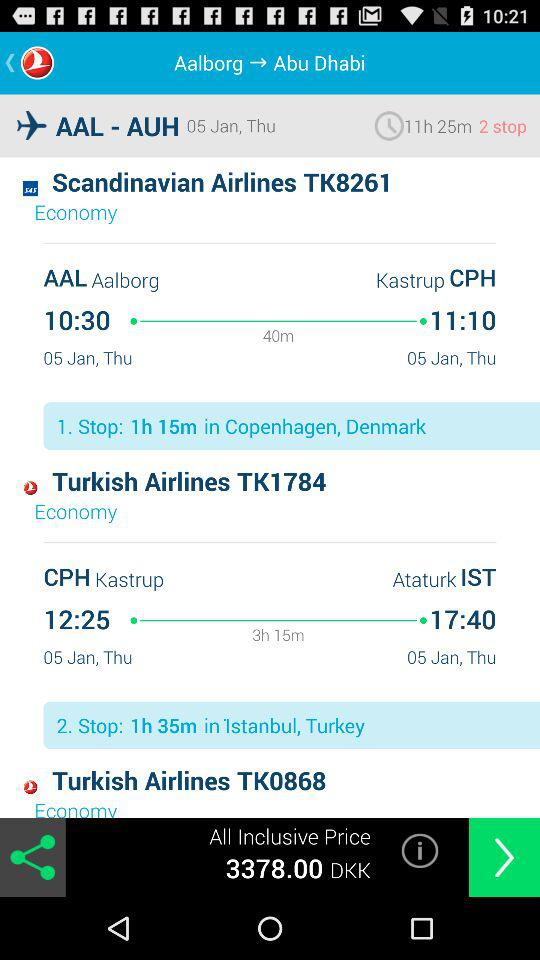What is the departure date of "Scandinavian Airlines TK8261"? The departure date of "Scandinavian Airlines TK8261" is Thursday, January 5. 